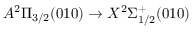Convert formula to latex. <formula><loc_0><loc_0><loc_500><loc_500>A ^ { 2 } \Pi _ { 3 / 2 } ( 0 1 0 ) \rightarrow X ^ { 2 } \Sigma _ { 1 / 2 } ^ { + } ( 0 1 0 )</formula> 